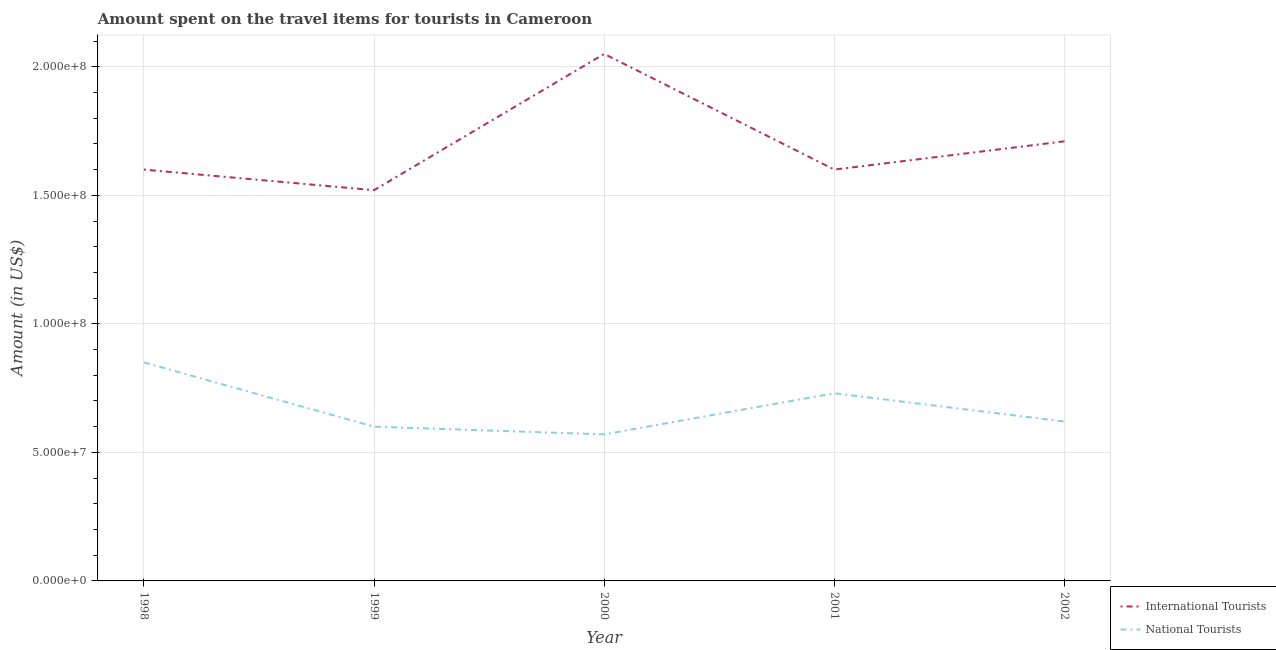How many different coloured lines are there?
Offer a very short reply. 2. Is the number of lines equal to the number of legend labels?
Keep it short and to the point. Yes. What is the amount spent on travel items of international tourists in 2000?
Ensure brevity in your answer.  2.05e+08. Across all years, what is the maximum amount spent on travel items of international tourists?
Provide a short and direct response. 2.05e+08. Across all years, what is the minimum amount spent on travel items of national tourists?
Give a very brief answer. 5.70e+07. In which year was the amount spent on travel items of international tourists maximum?
Keep it short and to the point. 2000. What is the total amount spent on travel items of national tourists in the graph?
Offer a very short reply. 3.37e+08. What is the difference between the amount spent on travel items of international tourists in 1999 and that in 2002?
Make the answer very short. -1.90e+07. What is the difference between the amount spent on travel items of international tourists in 2002 and the amount spent on travel items of national tourists in 2000?
Make the answer very short. 1.14e+08. What is the average amount spent on travel items of international tourists per year?
Keep it short and to the point. 1.70e+08. In the year 2002, what is the difference between the amount spent on travel items of international tourists and amount spent on travel items of national tourists?
Provide a succinct answer. 1.09e+08. What is the ratio of the amount spent on travel items of national tourists in 1998 to that in 2001?
Your response must be concise. 1.16. What is the difference between the highest and the second highest amount spent on travel items of international tourists?
Ensure brevity in your answer.  3.40e+07. What is the difference between the highest and the lowest amount spent on travel items of international tourists?
Provide a short and direct response. 5.30e+07. In how many years, is the amount spent on travel items of international tourists greater than the average amount spent on travel items of international tourists taken over all years?
Offer a very short reply. 2. How many lines are there?
Ensure brevity in your answer.  2. How many years are there in the graph?
Offer a very short reply. 5. Does the graph contain any zero values?
Ensure brevity in your answer.  No. Does the graph contain grids?
Provide a short and direct response. Yes. How many legend labels are there?
Your answer should be compact. 2. What is the title of the graph?
Keep it short and to the point. Amount spent on the travel items for tourists in Cameroon. Does "Central government" appear as one of the legend labels in the graph?
Your response must be concise. No. What is the label or title of the Y-axis?
Your answer should be compact. Amount (in US$). What is the Amount (in US$) of International Tourists in 1998?
Ensure brevity in your answer.  1.60e+08. What is the Amount (in US$) of National Tourists in 1998?
Your answer should be very brief. 8.50e+07. What is the Amount (in US$) of International Tourists in 1999?
Your response must be concise. 1.52e+08. What is the Amount (in US$) in National Tourists in 1999?
Your response must be concise. 6.00e+07. What is the Amount (in US$) of International Tourists in 2000?
Offer a very short reply. 2.05e+08. What is the Amount (in US$) in National Tourists in 2000?
Your answer should be compact. 5.70e+07. What is the Amount (in US$) of International Tourists in 2001?
Provide a short and direct response. 1.60e+08. What is the Amount (in US$) of National Tourists in 2001?
Provide a succinct answer. 7.30e+07. What is the Amount (in US$) of International Tourists in 2002?
Provide a succinct answer. 1.71e+08. What is the Amount (in US$) of National Tourists in 2002?
Offer a very short reply. 6.20e+07. Across all years, what is the maximum Amount (in US$) of International Tourists?
Make the answer very short. 2.05e+08. Across all years, what is the maximum Amount (in US$) of National Tourists?
Provide a short and direct response. 8.50e+07. Across all years, what is the minimum Amount (in US$) in International Tourists?
Your answer should be very brief. 1.52e+08. Across all years, what is the minimum Amount (in US$) of National Tourists?
Offer a terse response. 5.70e+07. What is the total Amount (in US$) in International Tourists in the graph?
Make the answer very short. 8.48e+08. What is the total Amount (in US$) of National Tourists in the graph?
Provide a short and direct response. 3.37e+08. What is the difference between the Amount (in US$) in International Tourists in 1998 and that in 1999?
Ensure brevity in your answer.  8.00e+06. What is the difference between the Amount (in US$) in National Tourists in 1998 and that in 1999?
Your response must be concise. 2.50e+07. What is the difference between the Amount (in US$) of International Tourists in 1998 and that in 2000?
Give a very brief answer. -4.50e+07. What is the difference between the Amount (in US$) in National Tourists in 1998 and that in 2000?
Provide a short and direct response. 2.80e+07. What is the difference between the Amount (in US$) of International Tourists in 1998 and that in 2001?
Make the answer very short. 0. What is the difference between the Amount (in US$) of International Tourists in 1998 and that in 2002?
Provide a short and direct response. -1.10e+07. What is the difference between the Amount (in US$) of National Tourists in 1998 and that in 2002?
Give a very brief answer. 2.30e+07. What is the difference between the Amount (in US$) in International Tourists in 1999 and that in 2000?
Your answer should be compact. -5.30e+07. What is the difference between the Amount (in US$) of National Tourists in 1999 and that in 2000?
Make the answer very short. 3.00e+06. What is the difference between the Amount (in US$) of International Tourists in 1999 and that in 2001?
Your answer should be compact. -8.00e+06. What is the difference between the Amount (in US$) of National Tourists in 1999 and that in 2001?
Give a very brief answer. -1.30e+07. What is the difference between the Amount (in US$) of International Tourists in 1999 and that in 2002?
Your response must be concise. -1.90e+07. What is the difference between the Amount (in US$) in International Tourists in 2000 and that in 2001?
Offer a terse response. 4.50e+07. What is the difference between the Amount (in US$) in National Tourists in 2000 and that in 2001?
Provide a short and direct response. -1.60e+07. What is the difference between the Amount (in US$) of International Tourists in 2000 and that in 2002?
Your response must be concise. 3.40e+07. What is the difference between the Amount (in US$) in National Tourists in 2000 and that in 2002?
Ensure brevity in your answer.  -5.00e+06. What is the difference between the Amount (in US$) in International Tourists in 2001 and that in 2002?
Offer a terse response. -1.10e+07. What is the difference between the Amount (in US$) of National Tourists in 2001 and that in 2002?
Make the answer very short. 1.10e+07. What is the difference between the Amount (in US$) of International Tourists in 1998 and the Amount (in US$) of National Tourists in 1999?
Offer a very short reply. 1.00e+08. What is the difference between the Amount (in US$) in International Tourists in 1998 and the Amount (in US$) in National Tourists in 2000?
Provide a short and direct response. 1.03e+08. What is the difference between the Amount (in US$) in International Tourists in 1998 and the Amount (in US$) in National Tourists in 2001?
Your response must be concise. 8.70e+07. What is the difference between the Amount (in US$) of International Tourists in 1998 and the Amount (in US$) of National Tourists in 2002?
Give a very brief answer. 9.80e+07. What is the difference between the Amount (in US$) in International Tourists in 1999 and the Amount (in US$) in National Tourists in 2000?
Make the answer very short. 9.50e+07. What is the difference between the Amount (in US$) in International Tourists in 1999 and the Amount (in US$) in National Tourists in 2001?
Make the answer very short. 7.90e+07. What is the difference between the Amount (in US$) in International Tourists in 1999 and the Amount (in US$) in National Tourists in 2002?
Make the answer very short. 9.00e+07. What is the difference between the Amount (in US$) of International Tourists in 2000 and the Amount (in US$) of National Tourists in 2001?
Make the answer very short. 1.32e+08. What is the difference between the Amount (in US$) of International Tourists in 2000 and the Amount (in US$) of National Tourists in 2002?
Keep it short and to the point. 1.43e+08. What is the difference between the Amount (in US$) in International Tourists in 2001 and the Amount (in US$) in National Tourists in 2002?
Your response must be concise. 9.80e+07. What is the average Amount (in US$) of International Tourists per year?
Keep it short and to the point. 1.70e+08. What is the average Amount (in US$) in National Tourists per year?
Offer a very short reply. 6.74e+07. In the year 1998, what is the difference between the Amount (in US$) of International Tourists and Amount (in US$) of National Tourists?
Offer a very short reply. 7.50e+07. In the year 1999, what is the difference between the Amount (in US$) of International Tourists and Amount (in US$) of National Tourists?
Give a very brief answer. 9.20e+07. In the year 2000, what is the difference between the Amount (in US$) of International Tourists and Amount (in US$) of National Tourists?
Provide a succinct answer. 1.48e+08. In the year 2001, what is the difference between the Amount (in US$) of International Tourists and Amount (in US$) of National Tourists?
Provide a short and direct response. 8.70e+07. In the year 2002, what is the difference between the Amount (in US$) of International Tourists and Amount (in US$) of National Tourists?
Offer a very short reply. 1.09e+08. What is the ratio of the Amount (in US$) in International Tourists in 1998 to that in 1999?
Offer a terse response. 1.05. What is the ratio of the Amount (in US$) in National Tourists in 1998 to that in 1999?
Offer a very short reply. 1.42. What is the ratio of the Amount (in US$) in International Tourists in 1998 to that in 2000?
Ensure brevity in your answer.  0.78. What is the ratio of the Amount (in US$) of National Tourists in 1998 to that in 2000?
Offer a terse response. 1.49. What is the ratio of the Amount (in US$) of National Tourists in 1998 to that in 2001?
Your answer should be compact. 1.16. What is the ratio of the Amount (in US$) of International Tourists in 1998 to that in 2002?
Offer a terse response. 0.94. What is the ratio of the Amount (in US$) in National Tourists in 1998 to that in 2002?
Give a very brief answer. 1.37. What is the ratio of the Amount (in US$) of International Tourists in 1999 to that in 2000?
Your response must be concise. 0.74. What is the ratio of the Amount (in US$) of National Tourists in 1999 to that in 2000?
Keep it short and to the point. 1.05. What is the ratio of the Amount (in US$) of International Tourists in 1999 to that in 2001?
Give a very brief answer. 0.95. What is the ratio of the Amount (in US$) in National Tourists in 1999 to that in 2001?
Offer a very short reply. 0.82. What is the ratio of the Amount (in US$) in International Tourists in 1999 to that in 2002?
Offer a very short reply. 0.89. What is the ratio of the Amount (in US$) in National Tourists in 1999 to that in 2002?
Provide a short and direct response. 0.97. What is the ratio of the Amount (in US$) of International Tourists in 2000 to that in 2001?
Ensure brevity in your answer.  1.28. What is the ratio of the Amount (in US$) in National Tourists in 2000 to that in 2001?
Your response must be concise. 0.78. What is the ratio of the Amount (in US$) in International Tourists in 2000 to that in 2002?
Make the answer very short. 1.2. What is the ratio of the Amount (in US$) of National Tourists in 2000 to that in 2002?
Keep it short and to the point. 0.92. What is the ratio of the Amount (in US$) of International Tourists in 2001 to that in 2002?
Your answer should be compact. 0.94. What is the ratio of the Amount (in US$) of National Tourists in 2001 to that in 2002?
Ensure brevity in your answer.  1.18. What is the difference between the highest and the second highest Amount (in US$) of International Tourists?
Provide a short and direct response. 3.40e+07. What is the difference between the highest and the second highest Amount (in US$) of National Tourists?
Give a very brief answer. 1.20e+07. What is the difference between the highest and the lowest Amount (in US$) in International Tourists?
Make the answer very short. 5.30e+07. What is the difference between the highest and the lowest Amount (in US$) in National Tourists?
Make the answer very short. 2.80e+07. 